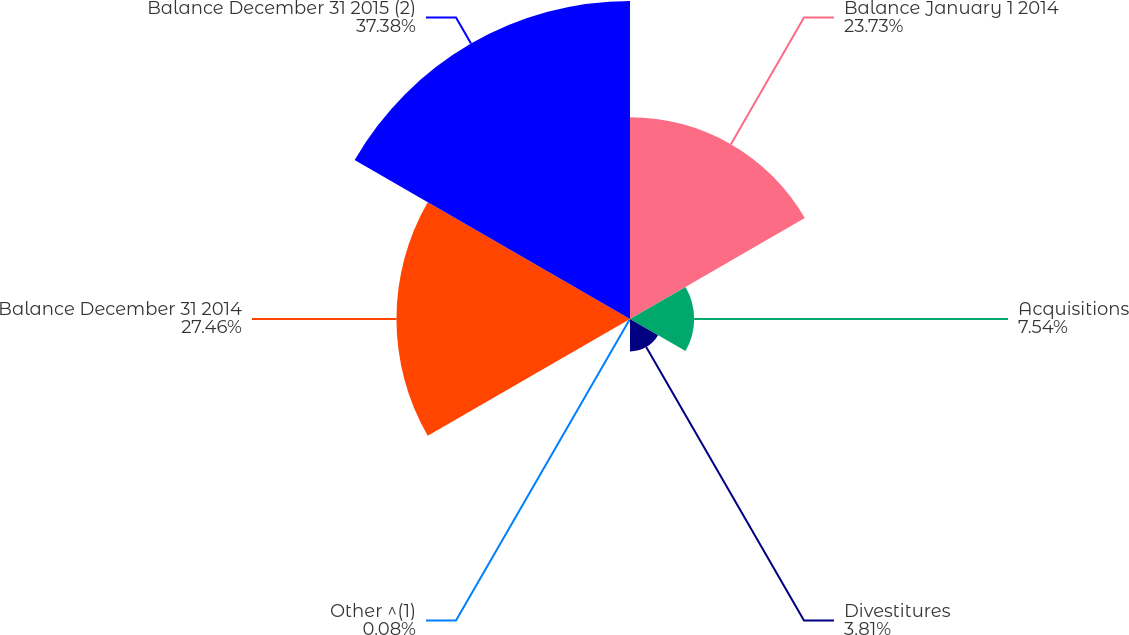Convert chart to OTSL. <chart><loc_0><loc_0><loc_500><loc_500><pie_chart><fcel>Balance January 1 2014<fcel>Acquisitions<fcel>Divestitures<fcel>Other ^(1)<fcel>Balance December 31 2014<fcel>Balance December 31 2015 (2)<nl><fcel>23.73%<fcel>7.54%<fcel>3.81%<fcel>0.08%<fcel>27.46%<fcel>37.39%<nl></chart> 